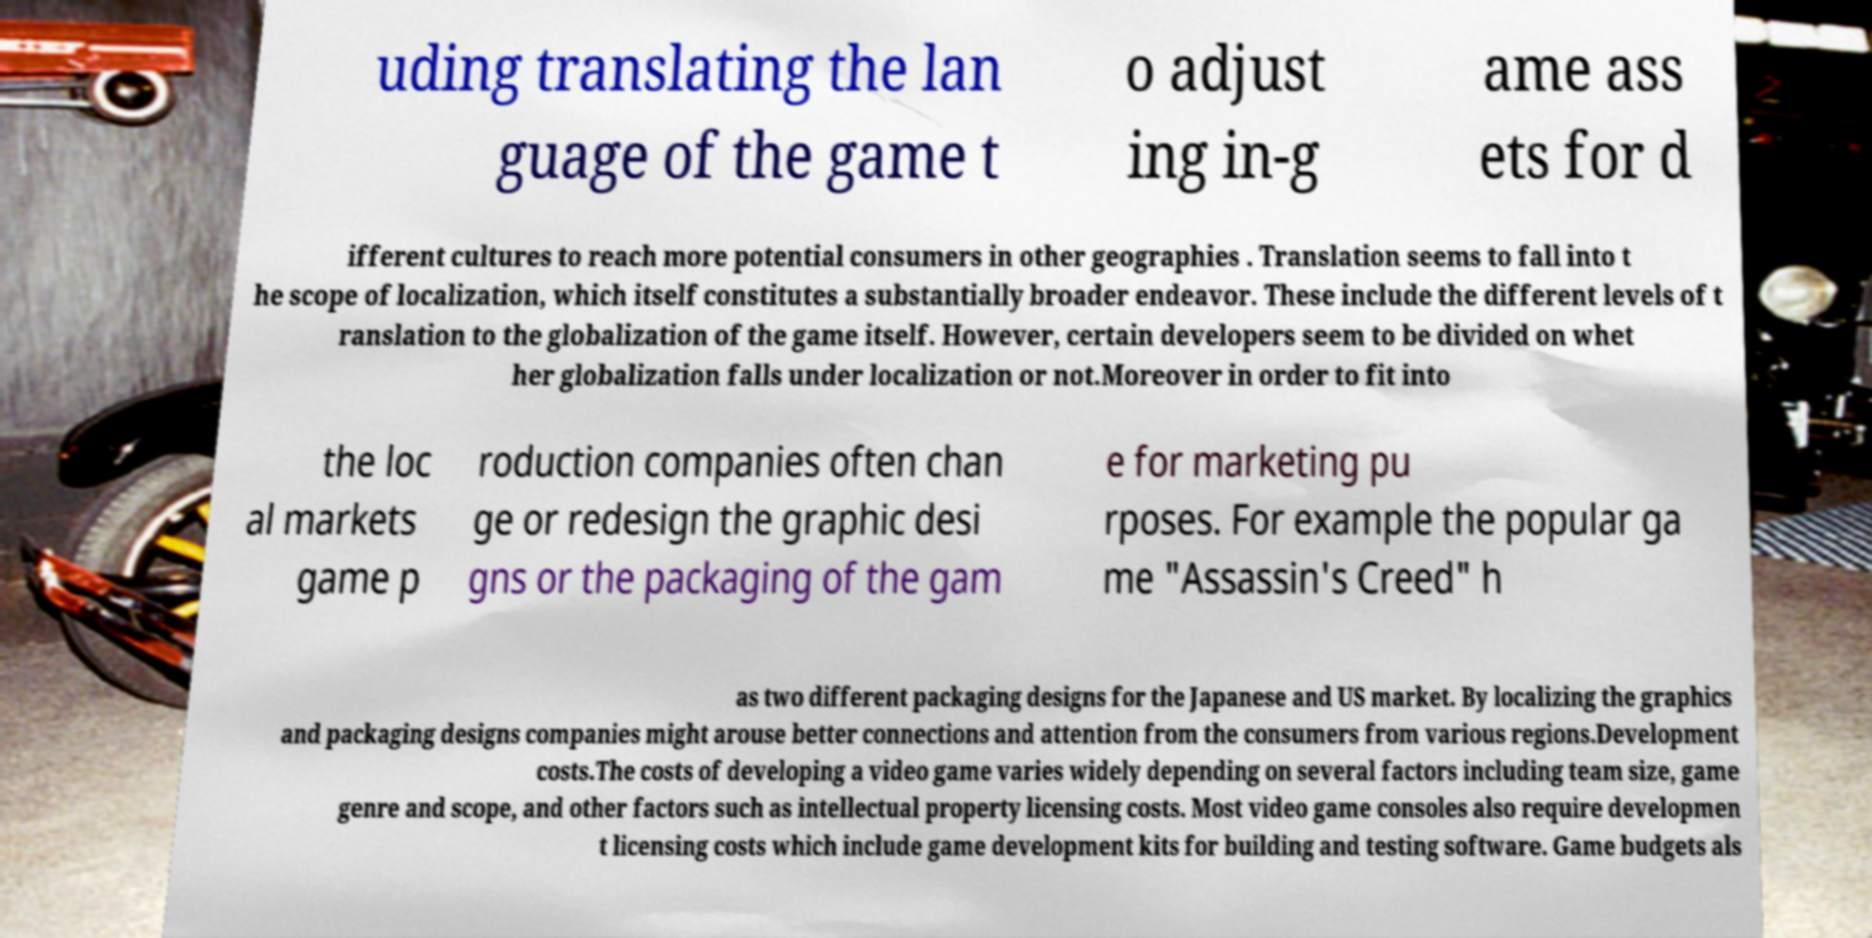Could you extract and type out the text from this image? uding translating the lan guage of the game t o adjust ing in-g ame ass ets for d ifferent cultures to reach more potential consumers in other geographies . Translation seems to fall into t he scope of localization, which itself constitutes a substantially broader endeavor. These include the different levels of t ranslation to the globalization of the game itself. However, certain developers seem to be divided on whet her globalization falls under localization or not.Moreover in order to fit into the loc al markets game p roduction companies often chan ge or redesign the graphic desi gns or the packaging of the gam e for marketing pu rposes. For example the popular ga me "Assassin's Creed" h as two different packaging designs for the Japanese and US market. By localizing the graphics and packaging designs companies might arouse better connections and attention from the consumers from various regions.Development costs.The costs of developing a video game varies widely depending on several factors including team size, game genre and scope, and other factors such as intellectual property licensing costs. Most video game consoles also require developmen t licensing costs which include game development kits for building and testing software. Game budgets als 